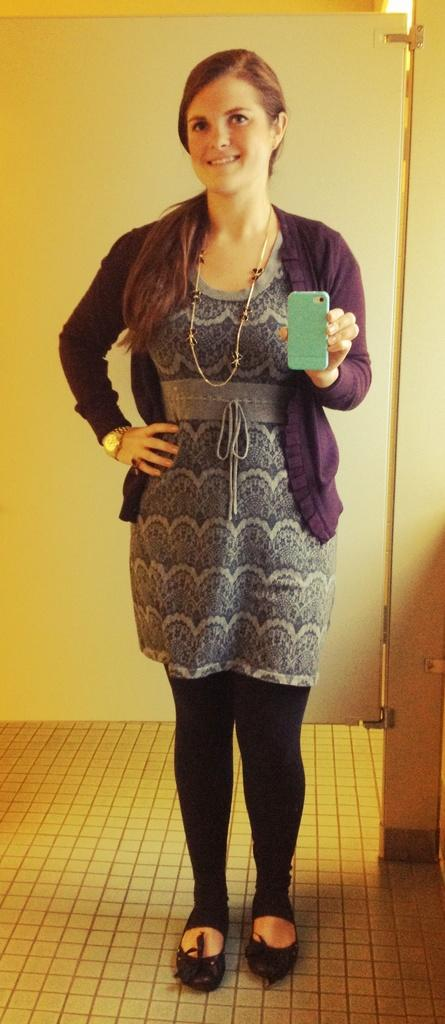Who is present in the image? There is a woman in the image. What is the woman doing in the image? The woman is standing in the image. What object is the woman holding? The woman is holding a mobile phone in the image. What architectural feature can be seen in the image? There is a door visible in the image. What type of pot is the woman using to make jam in the image? There is no pot or jam-making activity present in the image. What color is the sweater the woman is wearing in the image? The provided facts do not mention the woman wearing a sweater, so we cannot determine the color of a sweater in the image. 